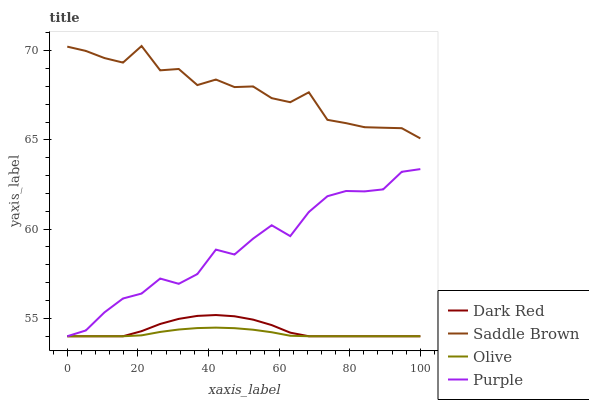Does Olive have the minimum area under the curve?
Answer yes or no. Yes. Does Saddle Brown have the maximum area under the curve?
Answer yes or no. Yes. Does Dark Red have the minimum area under the curve?
Answer yes or no. No. Does Dark Red have the maximum area under the curve?
Answer yes or no. No. Is Olive the smoothest?
Answer yes or no. Yes. Is Saddle Brown the roughest?
Answer yes or no. Yes. Is Dark Red the smoothest?
Answer yes or no. No. Is Dark Red the roughest?
Answer yes or no. No. Does Olive have the lowest value?
Answer yes or no. Yes. Does Saddle Brown have the lowest value?
Answer yes or no. No. Does Saddle Brown have the highest value?
Answer yes or no. Yes. Does Dark Red have the highest value?
Answer yes or no. No. Is Olive less than Saddle Brown?
Answer yes or no. Yes. Is Saddle Brown greater than Olive?
Answer yes or no. Yes. Does Purple intersect Dark Red?
Answer yes or no. Yes. Is Purple less than Dark Red?
Answer yes or no. No. Is Purple greater than Dark Red?
Answer yes or no. No. Does Olive intersect Saddle Brown?
Answer yes or no. No. 